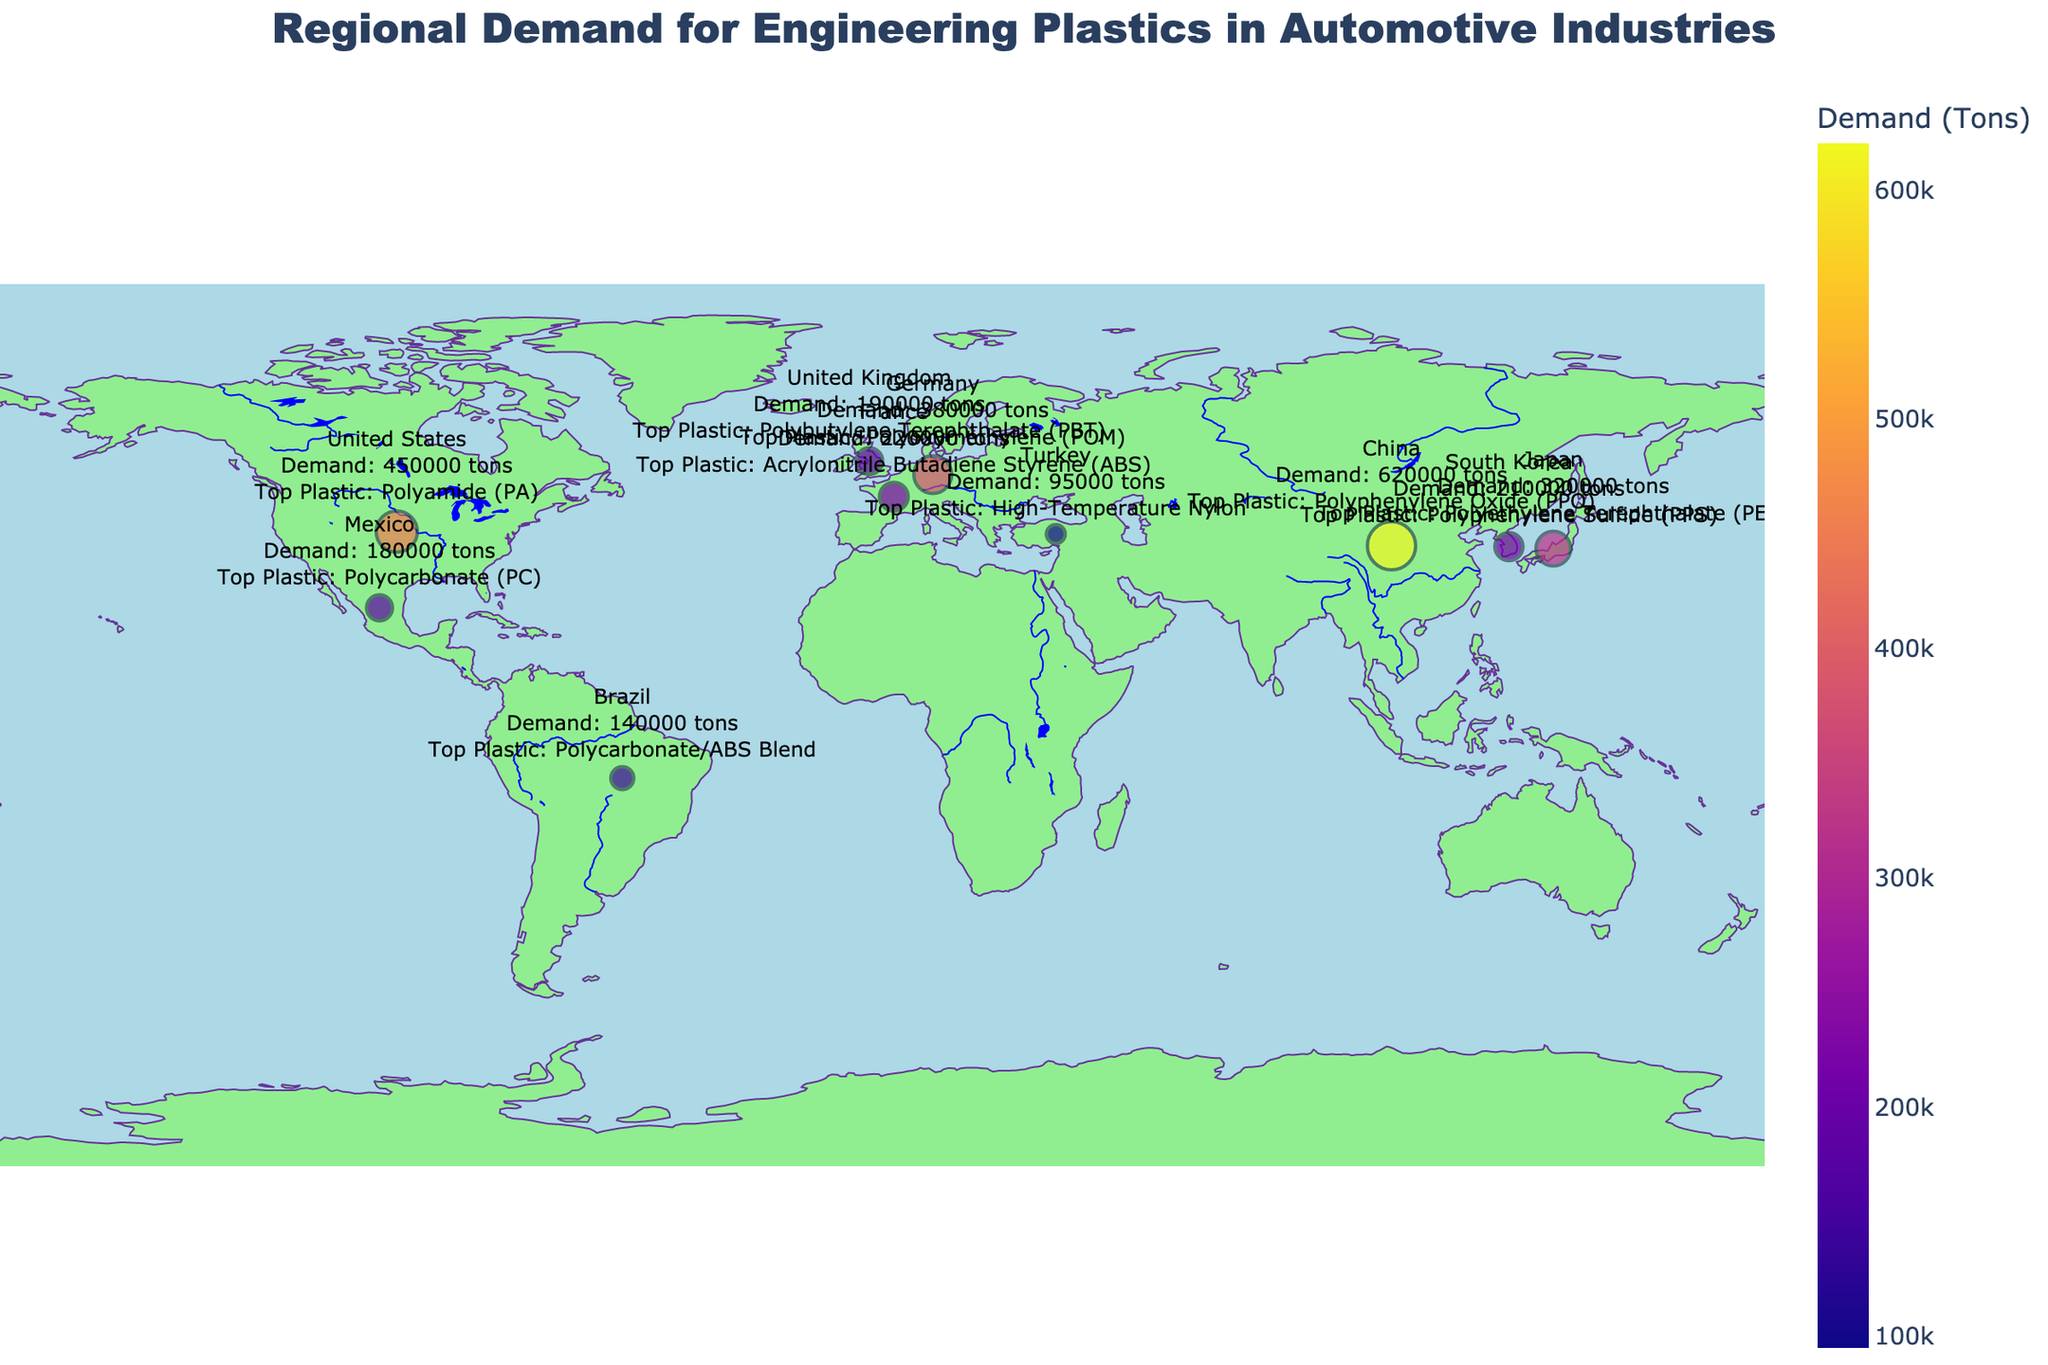What's the title of the figure? The title of the figure is at the top center. By looking there, you will see the text specifying the title of the plot.
Answer: Regional Demand for Engineering Plastics in Automotive Industries How many countries in Europe are represented in the figure? By counting the data points labeled as Germany, France, and the United Kingdom, you will find that there are three countries in Europe represented.
Answer: 3 Which country has the highest demand volume for engineering plastics? The largest data point on the figure corresponds to China, indicating that it has the highest demand volume.
Answer: China What is the top engineering plastic in North America? The hover text on the data points for the United States and Mexico in North America shows that the top engineering plastics are Polyamide (PA) and Polycarbonate (PC) respectively.
Answer: Polyamide (PA) and Polycarbonate (PC) Which Asian country has the least demand for engineering plastics, and what is the demand volume? By comparing the sizes of data points in Asia and reading the demand volumes, South Korea has the smallest point with a demand volume of 210,000 tons.
Answer: South Korea, 210,000 tons Compare the demand volume between Germany and France. Which country has a higher demand and by how much? Reading the demand volumes from the plot shows Germany with 380,000 tons and France with 220,000 tons. Subtracting these figures: 380,000 - 220,000 gives a difference of 160,000 tons.
Answer: Germany, 160,000 tons What is the color scale used to represent demand volumes in the figure? Observing the color gradient used on the map, you can see a sequential scale that transitions from light to dark colors, specifically using colors from the Plasma scale.
Answer: Plasma How does the demand volume of Brazil compare to Turkey's? Reading the demand volumes from their respective data points shows Brazil with 140,000 tons and Turkey with 95,000 tons. Brazil's demand is higher.
Answer: Brazil has higher demand What are the geographical regions represented in the figure? By observing the locations of all the data points, you find that the regions represented are North America, Europe, Asia, South America, and the Middle East.
Answer: North America, Europe, Asia, South America, Middle East What is the total demand volume for engineering plastics in Asia? Summing the demand volumes for China (620,000 tons), Japan (320,000 tons), and South Korea (210,000 tons) gives a total demand of 1,150,000 tons.
Answer: 1,150,000 tons 